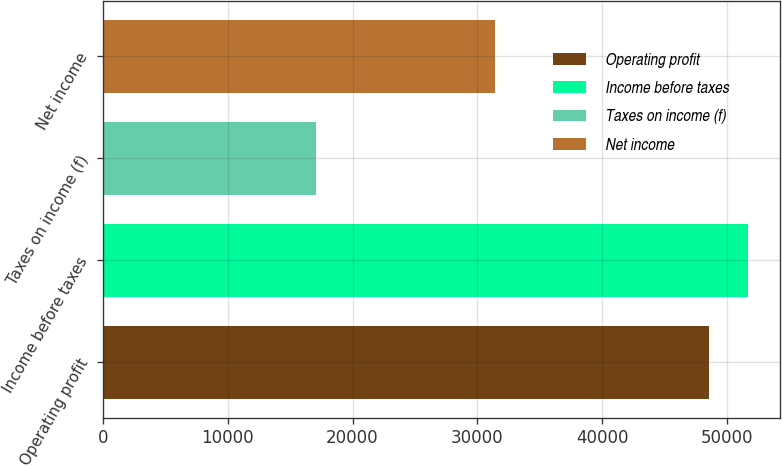<chart> <loc_0><loc_0><loc_500><loc_500><bar_chart><fcel>Operating profit<fcel>Income before taxes<fcel>Taxes on income (f)<fcel>Net income<nl><fcel>48518<fcel>51660.9<fcel>17089<fcel>31429<nl></chart> 